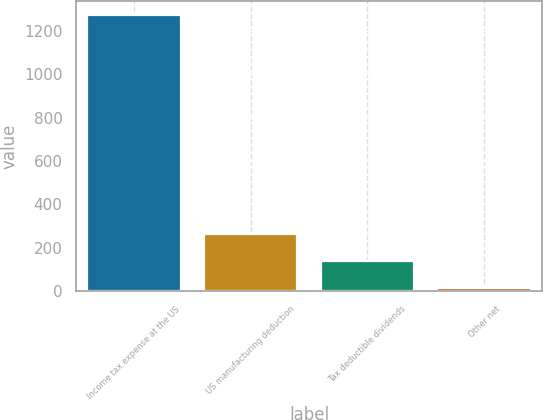<chart> <loc_0><loc_0><loc_500><loc_500><bar_chart><fcel>Income tax expense at the US<fcel>US manufacturing deduction<fcel>Tax deductible dividends<fcel>Other net<nl><fcel>1271<fcel>266.2<fcel>140.6<fcel>15<nl></chart> 